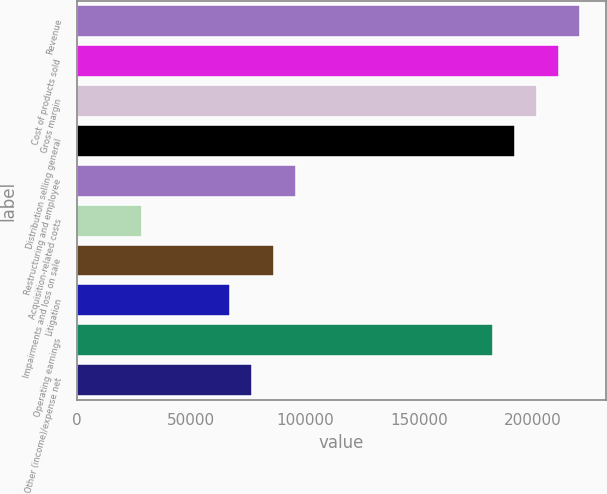Convert chart. <chart><loc_0><loc_0><loc_500><loc_500><bar_chart><fcel>Revenue<fcel>Cost of products sold<fcel>Gross margin<fcel>Distribution selling general<fcel>Restructuring and employee<fcel>Acquisition-related costs<fcel>Impairments and loss on sale<fcel>Litigation<fcel>Operating earnings<fcel>Other (income)/expense net<nl><fcel>220779<fcel>211180<fcel>201581<fcel>191982<fcel>95991.5<fcel>28798.2<fcel>86392.5<fcel>67194.4<fcel>182383<fcel>76793.4<nl></chart> 